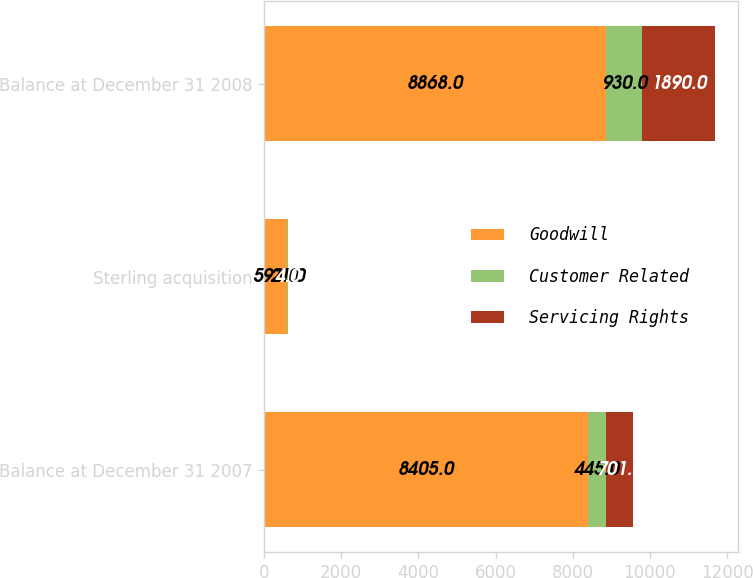Convert chart. <chart><loc_0><loc_0><loc_500><loc_500><stacked_bar_chart><ecel><fcel>Balance at December 31 2007<fcel>Sterling acquisition<fcel>Balance at December 31 2008<nl><fcel>Goodwill<fcel>8405<fcel>593<fcel>8868<nl><fcel>Customer Related<fcel>445<fcel>21<fcel>930<nl><fcel>Servicing Rights<fcel>701<fcel>4<fcel>1890<nl></chart> 